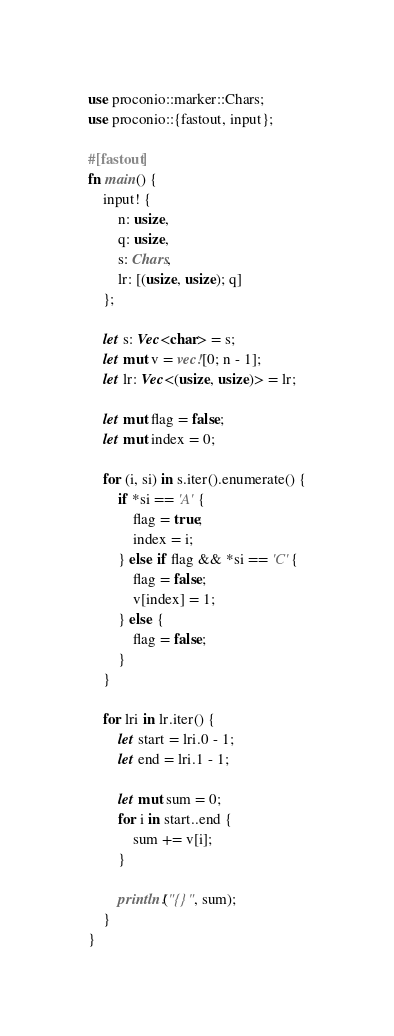Convert code to text. <code><loc_0><loc_0><loc_500><loc_500><_Rust_>use proconio::marker::Chars;
use proconio::{fastout, input};

#[fastout]
fn main() {
    input! {
        n: usize,
        q: usize,
        s: Chars,
        lr: [(usize, usize); q]
    };

    let s: Vec<char> = s;
    let mut v = vec![0; n - 1];
    let lr: Vec<(usize, usize)> = lr;

    let mut flag = false;
    let mut index = 0;

    for (i, si) in s.iter().enumerate() {
        if *si == 'A' {
            flag = true;
            index = i;
        } else if flag && *si == 'C' {
            flag = false;
            v[index] = 1;
        } else {
            flag = false;
        }
    }

    for lri in lr.iter() {
        let start = lri.0 - 1;
        let end = lri.1 - 1;

        let mut sum = 0;
        for i in start..end {
            sum += v[i];
        }

        println!("{}", sum);
    }
}
</code> 